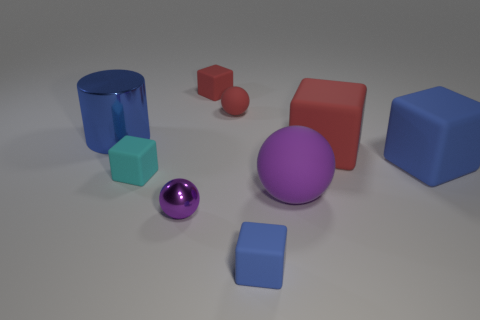Subtract all tiny red balls. How many balls are left? 2 Add 1 blue rubber objects. How many objects exist? 10 Subtract all cubes. How many objects are left? 4 Subtract 1 cylinders. How many cylinders are left? 0 Add 4 big blue cylinders. How many big blue cylinders are left? 5 Add 3 big red rubber objects. How many big red rubber objects exist? 4 Subtract all red spheres. How many spheres are left? 2 Subtract 0 gray cylinders. How many objects are left? 9 Subtract all green blocks. Subtract all cyan cylinders. How many blocks are left? 5 Subtract all purple spheres. How many yellow cubes are left? 0 